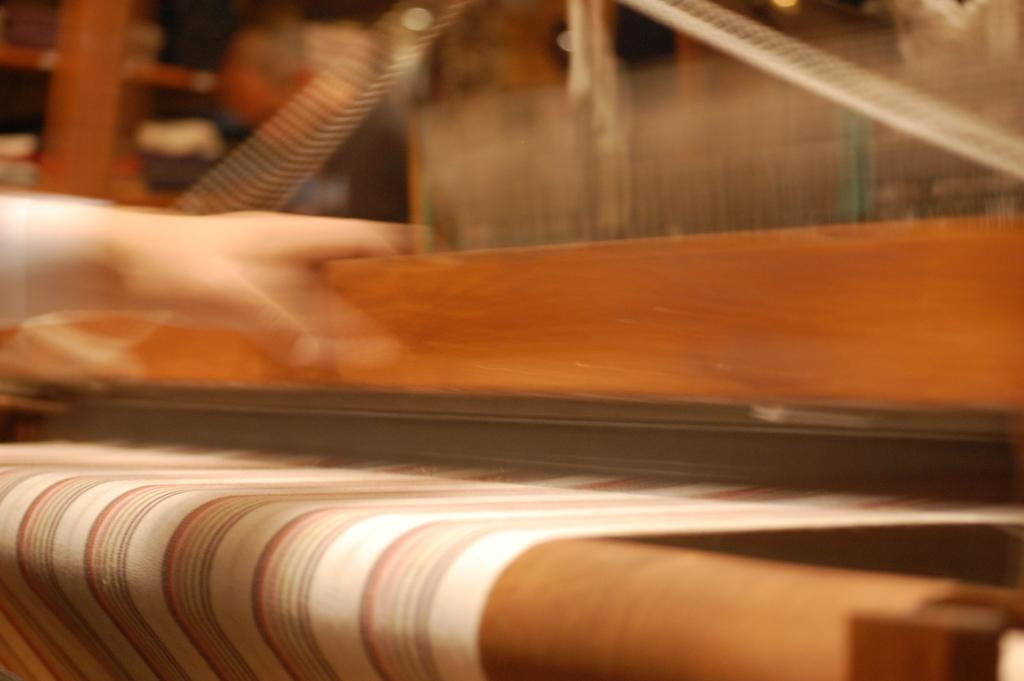What type of machine is in the image? There is a weaving machine in the image. What is on the weaving machine? The weaving machine has a cloth on it. Can you see any part of a person in the image? Yes, a person's hand is visible in the image. How would you describe the quality of the image? The image appears to be blurry. What type of health advice can be seen on the weaving machine in the image? There is no health advice visible on the weaving machine in the image. Can you see a kitten playing with the cloth on the weaving machine in the image? There is no kitten present in the image. 